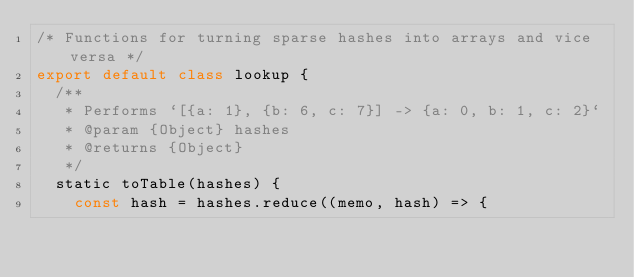Convert code to text. <code><loc_0><loc_0><loc_500><loc_500><_JavaScript_>/* Functions for turning sparse hashes into arrays and vice versa */
export default class lookup {
  /**
   * Performs `[{a: 1}, {b: 6, c: 7}] -> {a: 0, b: 1, c: 2}`
   * @param {Object} hashes
   * @returns {Object}
   */
  static toTable(hashes) {
    const hash = hashes.reduce((memo, hash) => {</code> 